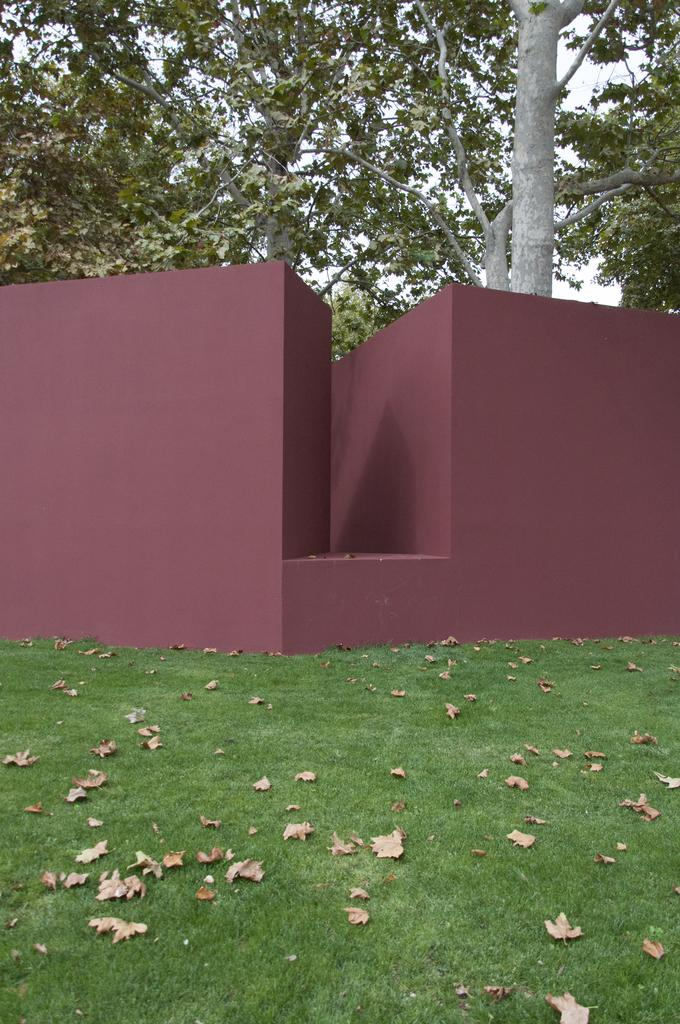What type of surface can be seen in the image? Ground is visible in the image. What type of vegetation is present on the ground? Shredded leaves are present in the image. What activity is taking place in the image? There is construction activity in the image. What type of natural elements are visible in the image? Trees are visible in the image. What part of the environment is visible above the ground? The sky is visible in the image. Can you see any spots on the wrist of the person in the image? There is no person present in the image, so it is not possible to see any spots on their wrist. 